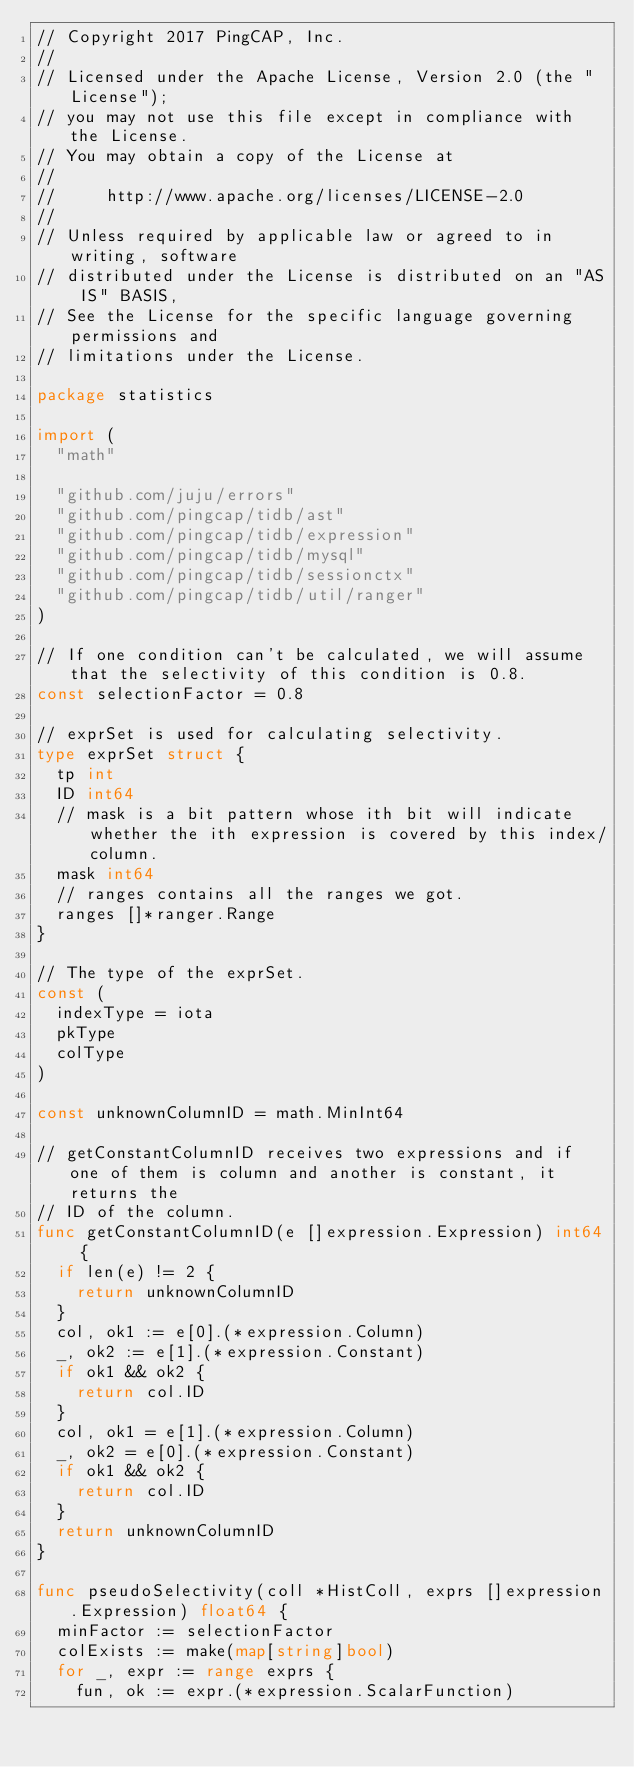Convert code to text. <code><loc_0><loc_0><loc_500><loc_500><_Go_>// Copyright 2017 PingCAP, Inc.
//
// Licensed under the Apache License, Version 2.0 (the "License");
// you may not use this file except in compliance with the License.
// You may obtain a copy of the License at
//
//     http://www.apache.org/licenses/LICENSE-2.0
//
// Unless required by applicable law or agreed to in writing, software
// distributed under the License is distributed on an "AS IS" BASIS,
// See the License for the specific language governing permissions and
// limitations under the License.

package statistics

import (
	"math"

	"github.com/juju/errors"
	"github.com/pingcap/tidb/ast"
	"github.com/pingcap/tidb/expression"
	"github.com/pingcap/tidb/mysql"
	"github.com/pingcap/tidb/sessionctx"
	"github.com/pingcap/tidb/util/ranger"
)

// If one condition can't be calculated, we will assume that the selectivity of this condition is 0.8.
const selectionFactor = 0.8

// exprSet is used for calculating selectivity.
type exprSet struct {
	tp int
	ID int64
	// mask is a bit pattern whose ith bit will indicate whether the ith expression is covered by this index/column.
	mask int64
	// ranges contains all the ranges we got.
	ranges []*ranger.Range
}

// The type of the exprSet.
const (
	indexType = iota
	pkType
	colType
)

const unknownColumnID = math.MinInt64

// getConstantColumnID receives two expressions and if one of them is column and another is constant, it returns the
// ID of the column.
func getConstantColumnID(e []expression.Expression) int64 {
	if len(e) != 2 {
		return unknownColumnID
	}
	col, ok1 := e[0].(*expression.Column)
	_, ok2 := e[1].(*expression.Constant)
	if ok1 && ok2 {
		return col.ID
	}
	col, ok1 = e[1].(*expression.Column)
	_, ok2 = e[0].(*expression.Constant)
	if ok1 && ok2 {
		return col.ID
	}
	return unknownColumnID
}

func pseudoSelectivity(coll *HistColl, exprs []expression.Expression) float64 {
	minFactor := selectionFactor
	colExists := make(map[string]bool)
	for _, expr := range exprs {
		fun, ok := expr.(*expression.ScalarFunction)</code> 